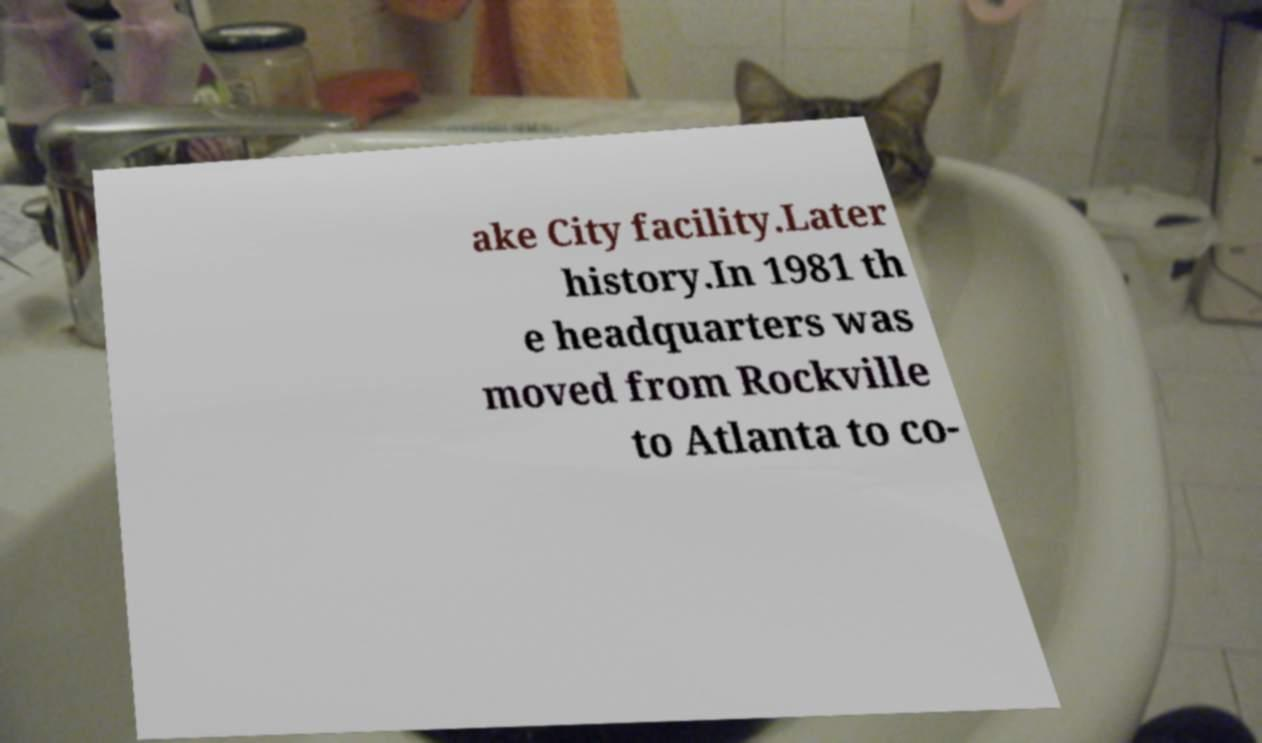For documentation purposes, I need the text within this image transcribed. Could you provide that? ake City facility.Later history.In 1981 th e headquarters was moved from Rockville to Atlanta to co- 